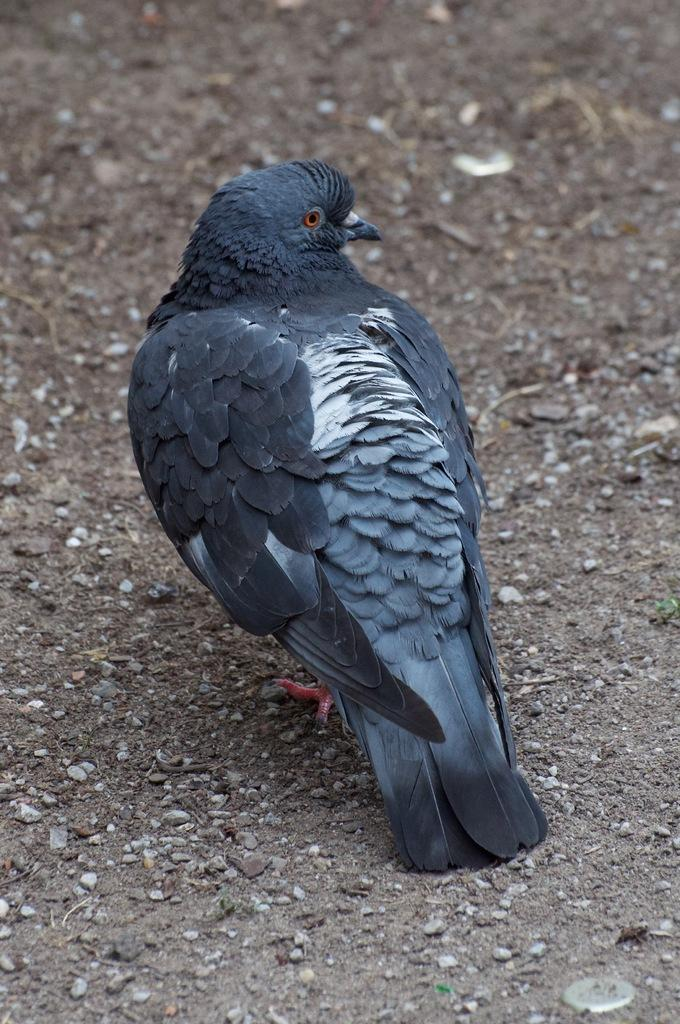What type of animal is in the image? There is a bird in the image. Where is the bird located in the image? The bird is on the ground. How many babies are crawling on the bird in the image? There are no babies present in the image, and the bird is on the ground, not being crawled on by any babies. 